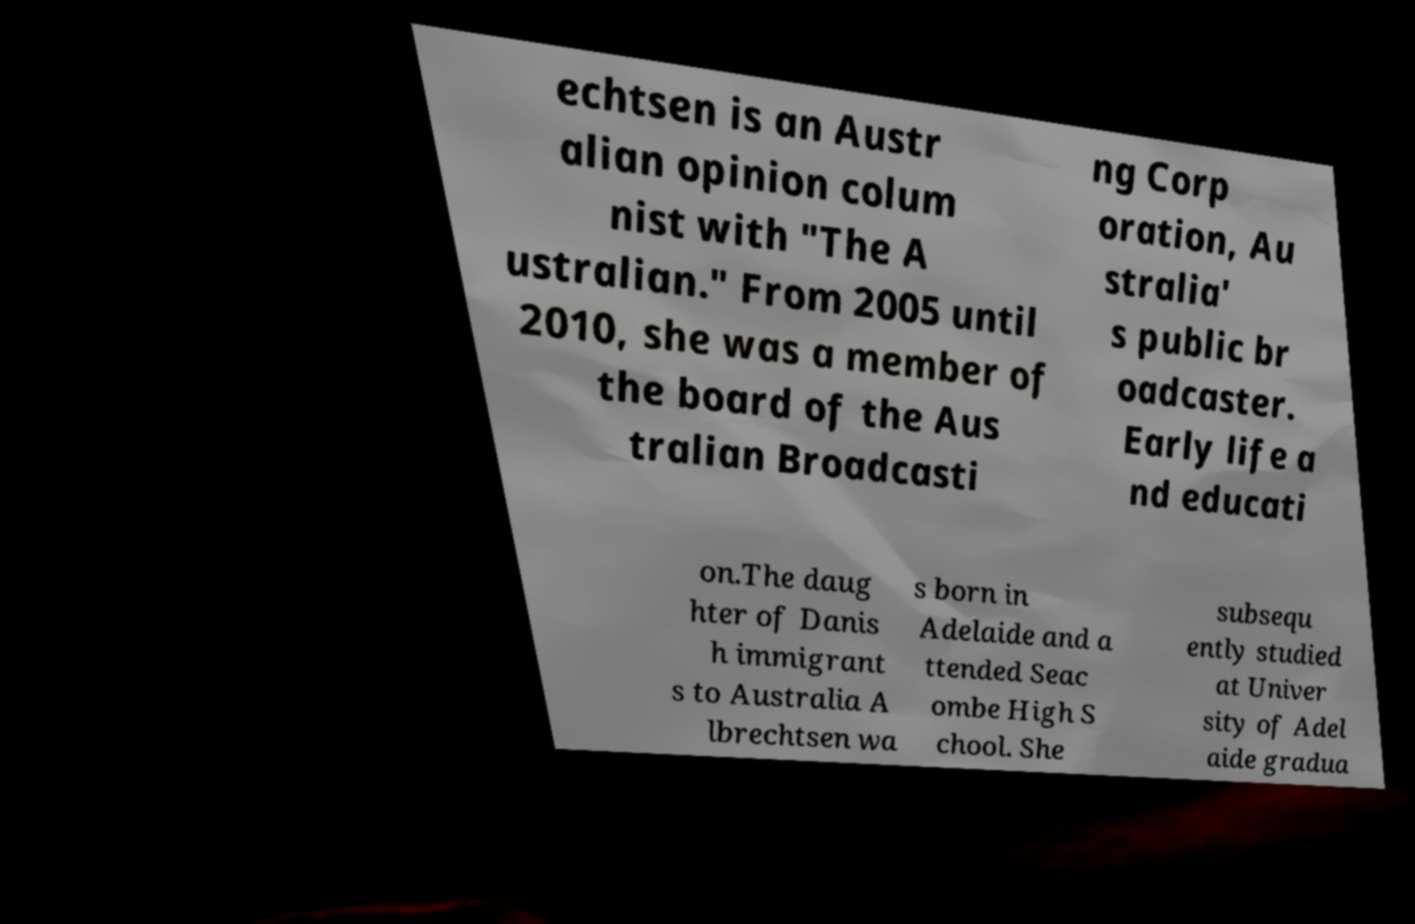For documentation purposes, I need the text within this image transcribed. Could you provide that? echtsen is an Austr alian opinion colum nist with "The A ustralian." From 2005 until 2010, she was a member of the board of the Aus tralian Broadcasti ng Corp oration, Au stralia' s public br oadcaster. Early life a nd educati on.The daug hter of Danis h immigrant s to Australia A lbrechtsen wa s born in Adelaide and a ttended Seac ombe High S chool. She subsequ ently studied at Univer sity of Adel aide gradua 